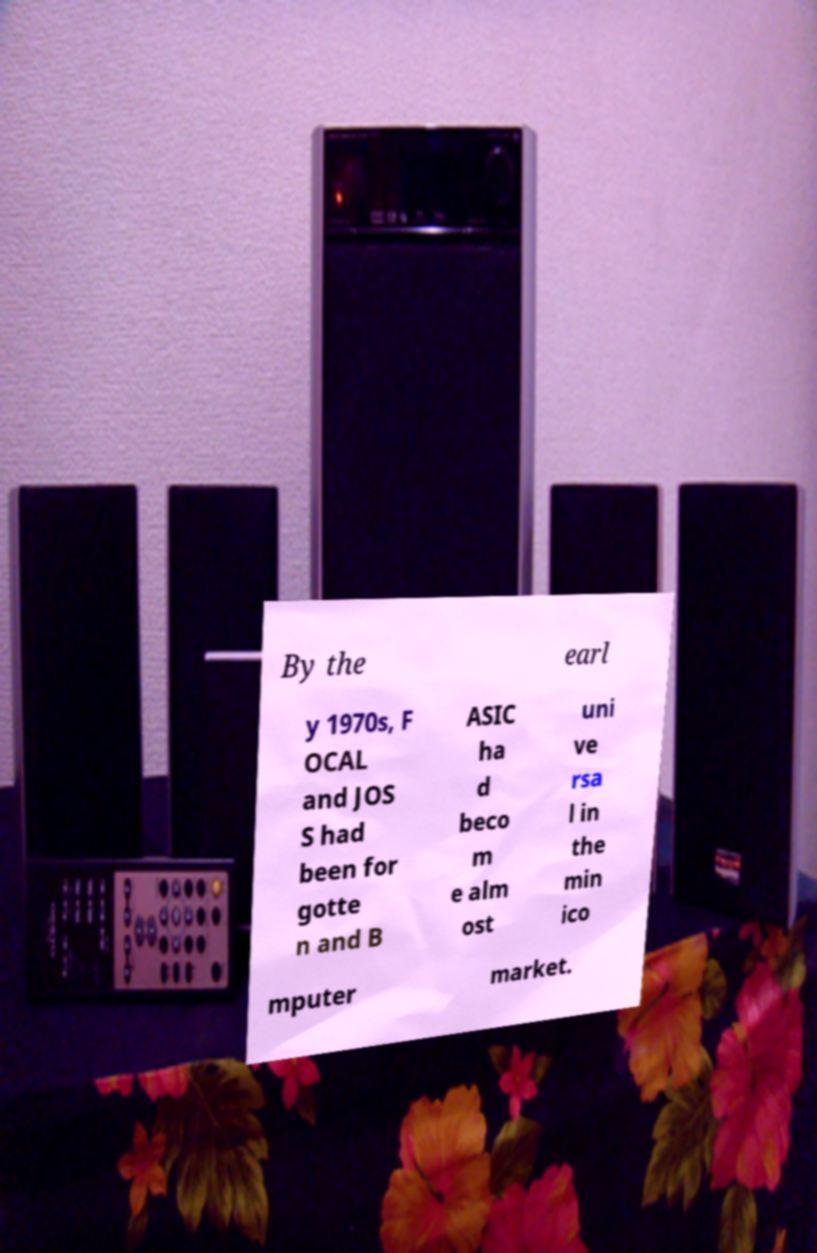Could you assist in decoding the text presented in this image and type it out clearly? By the earl y 1970s, F OCAL and JOS S had been for gotte n and B ASIC ha d beco m e alm ost uni ve rsa l in the min ico mputer market. 